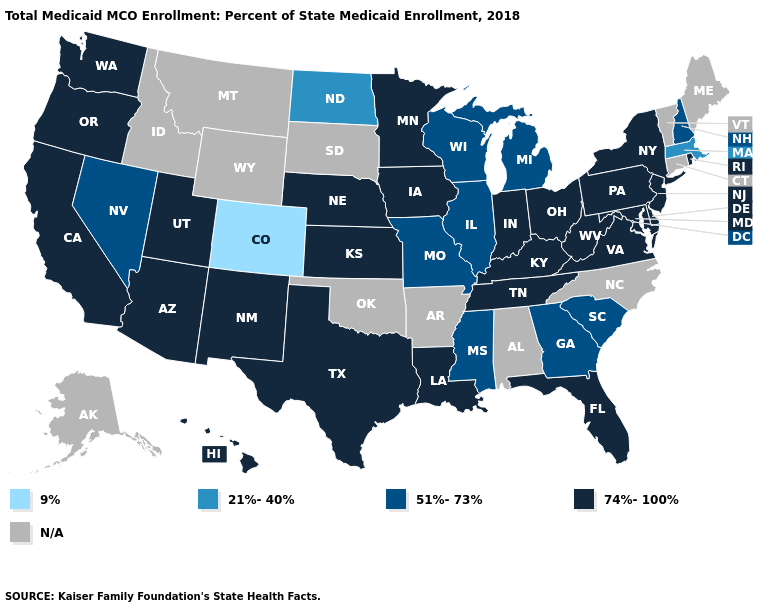Name the states that have a value in the range 51%-73%?
Quick response, please. Georgia, Illinois, Michigan, Mississippi, Missouri, Nevada, New Hampshire, South Carolina, Wisconsin. Name the states that have a value in the range 9%?
Quick response, please. Colorado. What is the highest value in the USA?
Give a very brief answer. 74%-100%. What is the lowest value in states that border West Virginia?
Short answer required. 74%-100%. What is the value of Nevada?
Write a very short answer. 51%-73%. What is the value of Kansas?
Short answer required. 74%-100%. What is the lowest value in states that border Missouri?
Answer briefly. 51%-73%. Among the states that border California , which have the highest value?
Keep it brief. Arizona, Oregon. Does Georgia have the highest value in the USA?
Write a very short answer. No. What is the highest value in the USA?
Write a very short answer. 74%-100%. What is the value of Utah?
Answer briefly. 74%-100%. How many symbols are there in the legend?
Be succinct. 5. Does the map have missing data?
Quick response, please. Yes. 